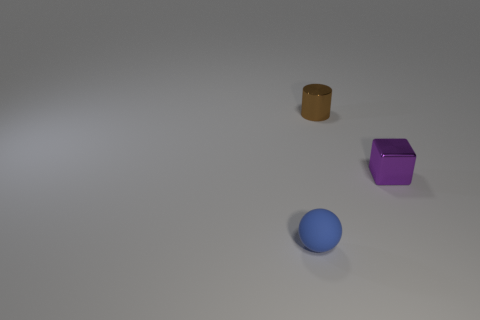There is a thing behind the small purple metallic block; is its color the same as the matte sphere?
Give a very brief answer. No. What is the size of the object in front of the tiny purple object?
Offer a terse response. Small. What is the shape of the blue matte object that is to the left of the small metallic thing in front of the metallic cylinder?
Offer a very short reply. Sphere. There is a metal thing that is right of the cylinder; is its size the same as the blue matte ball?
Your answer should be very brief. Yes. How many brown cylinders have the same material as the tiny purple thing?
Your response must be concise. 1. There is a thing that is on the left side of the thing that is behind the small metallic thing right of the brown metal cylinder; what is it made of?
Keep it short and to the point. Rubber. What is the color of the object to the left of the metal thing that is to the left of the tiny metal block?
Give a very brief answer. Blue. What is the color of the cylinder that is the same size as the rubber sphere?
Offer a very short reply. Brown. How many small things are brown things or matte balls?
Offer a very short reply. 2. Are there more objects in front of the small metal cylinder than tiny brown cylinders that are left of the tiny rubber object?
Keep it short and to the point. Yes. 